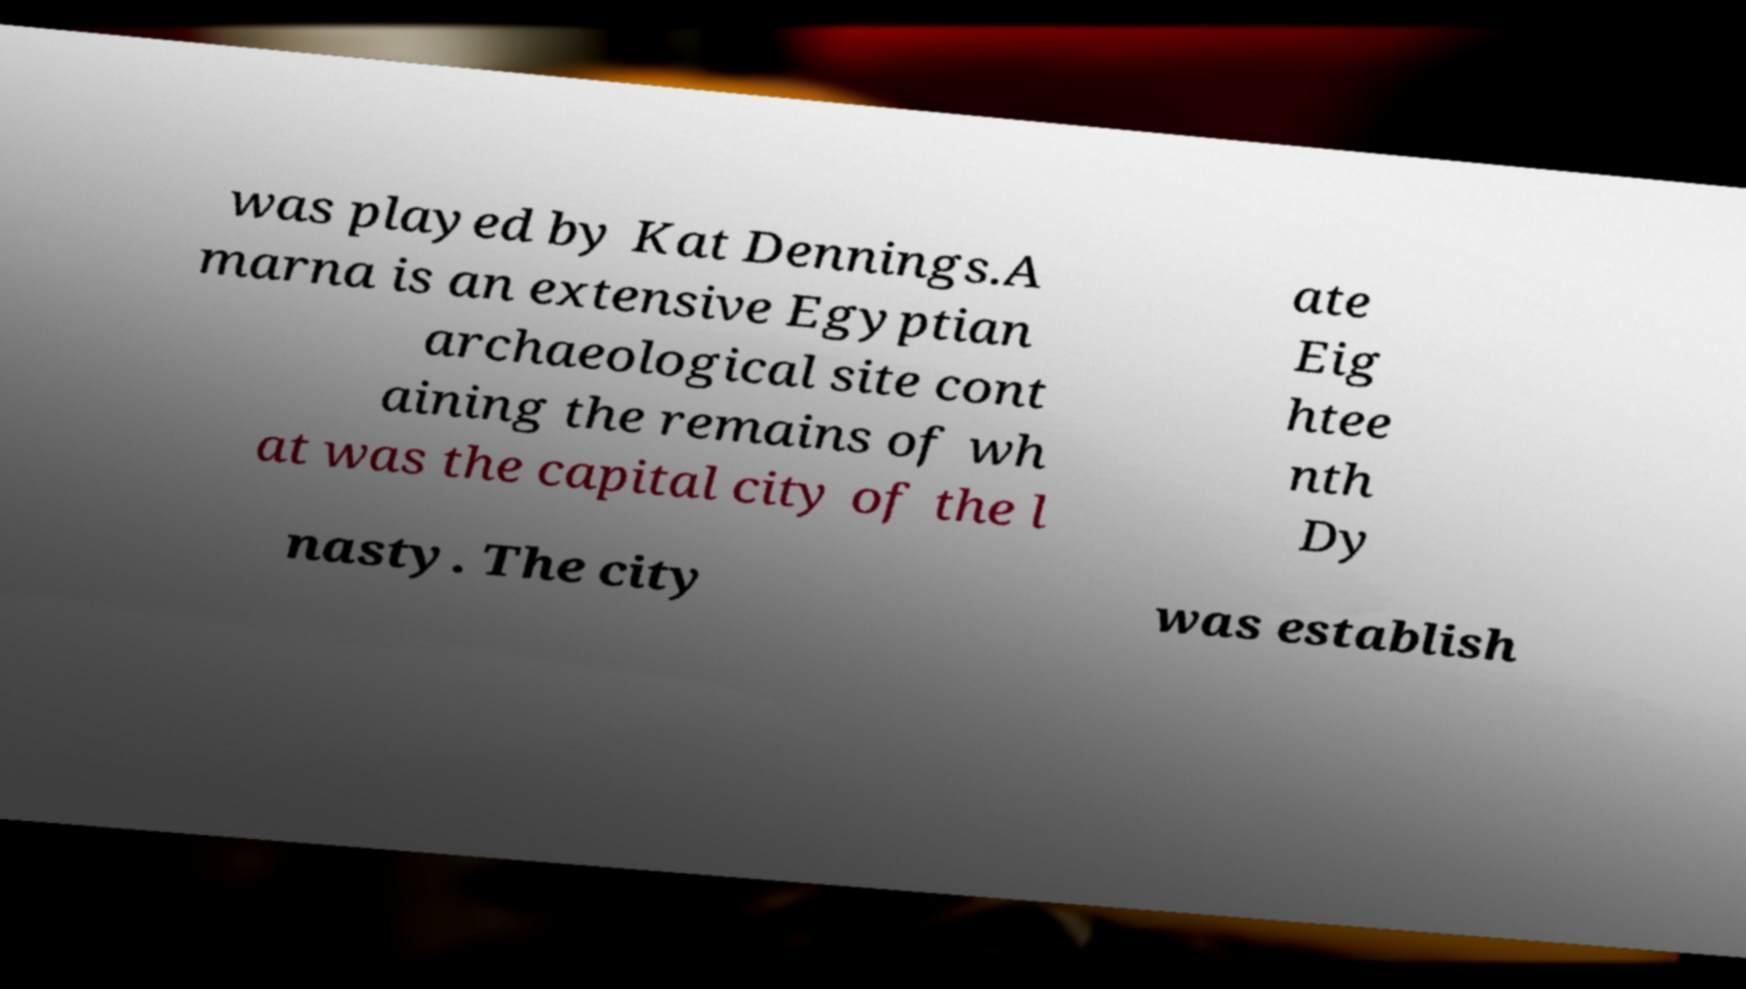Please read and relay the text visible in this image. What does it say? was played by Kat Dennings.A marna is an extensive Egyptian archaeological site cont aining the remains of wh at was the capital city of the l ate Eig htee nth Dy nasty. The city was establish 